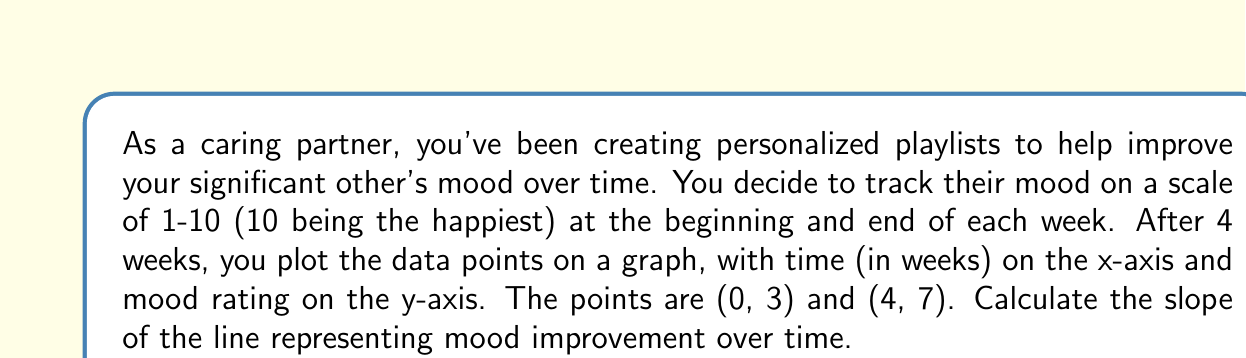Could you help me with this problem? To calculate the slope of a line given two points, we use the slope formula:

$$ m = \frac{y_2 - y_1}{x_2 - x_1} $$

Where $(x_1, y_1)$ is the first point and $(x_2, y_2)$ is the second point.

In this case:
$(x_1, y_1) = (0, 3)$ (initial point)
$(x_2, y_2) = (4, 7)$ (final point)

Let's substitute these values into the slope formula:

$$ m = \frac{7 - 3}{4 - 0} = \frac{4}{4} = 1 $$

The slope represents the rate of change in mood per week. A positive slope indicates an improvement in mood over time.
Answer: The slope of the line representing mood improvement over time is $1$ mood point per week. 